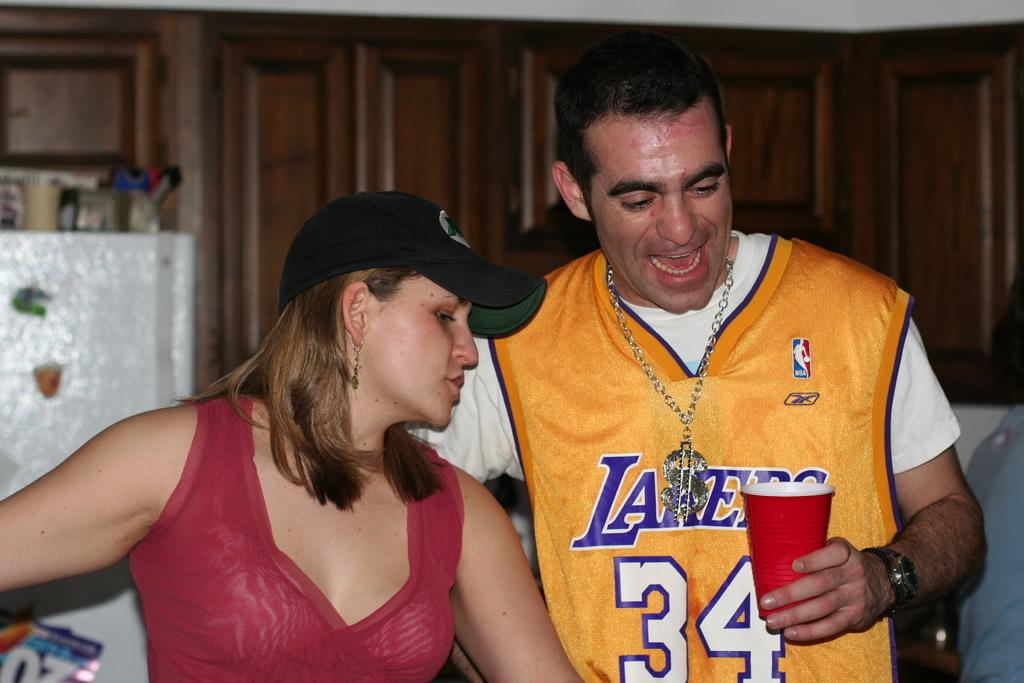<image>
Give a short and clear explanation of the subsequent image. A man wearing a Laker's jersey stands in a kitchen with a woman. 